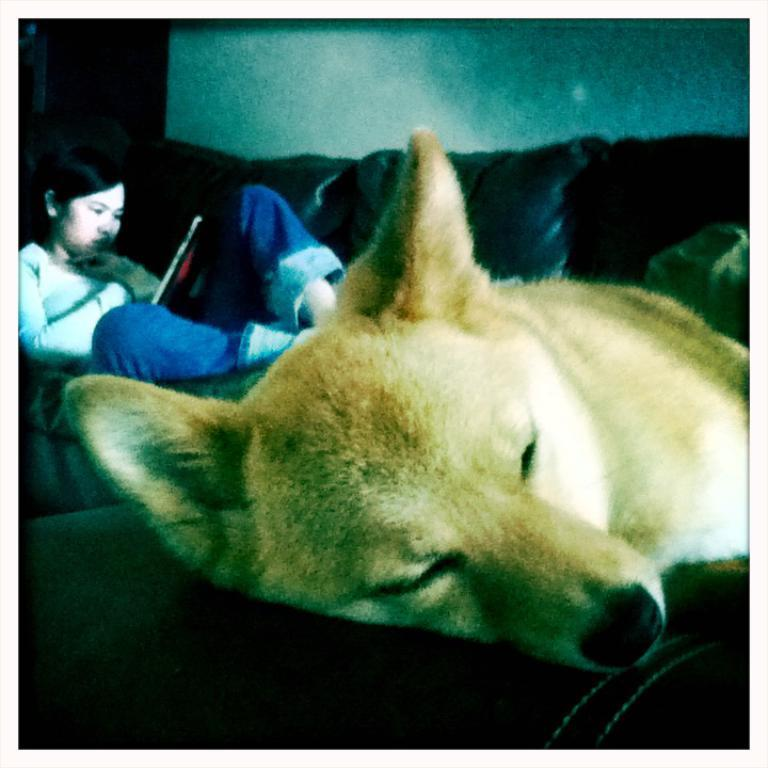Who is present in the image? There is a woman in the image. What is the woman doing in the image? The woman is seated on a sofa and holding a book. Are there any animals in the image? Yes, there is a dog in the image. Can you describe the dog's appearance? The dog is white and brown in color. What type of lip balm is the woman applying in the image? There is no lip balm or any indication of the woman applying anything in the image. 